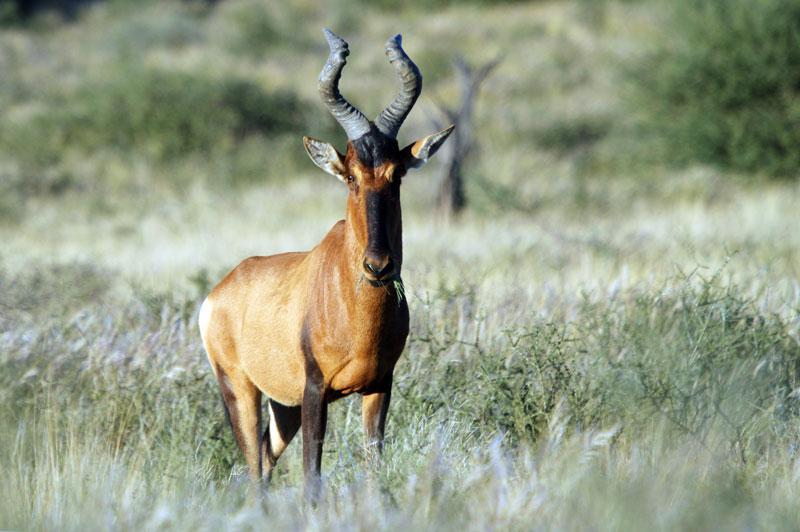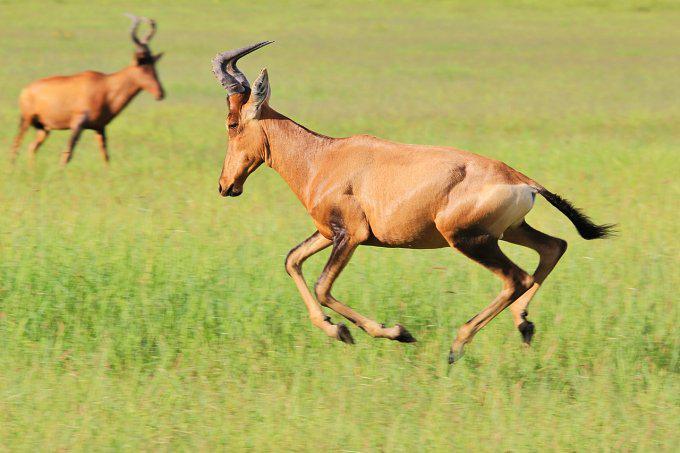The first image is the image on the left, the second image is the image on the right. Analyze the images presented: Is the assertion "The right hand image contains an animal facing left." valid? Answer yes or no. Yes. 